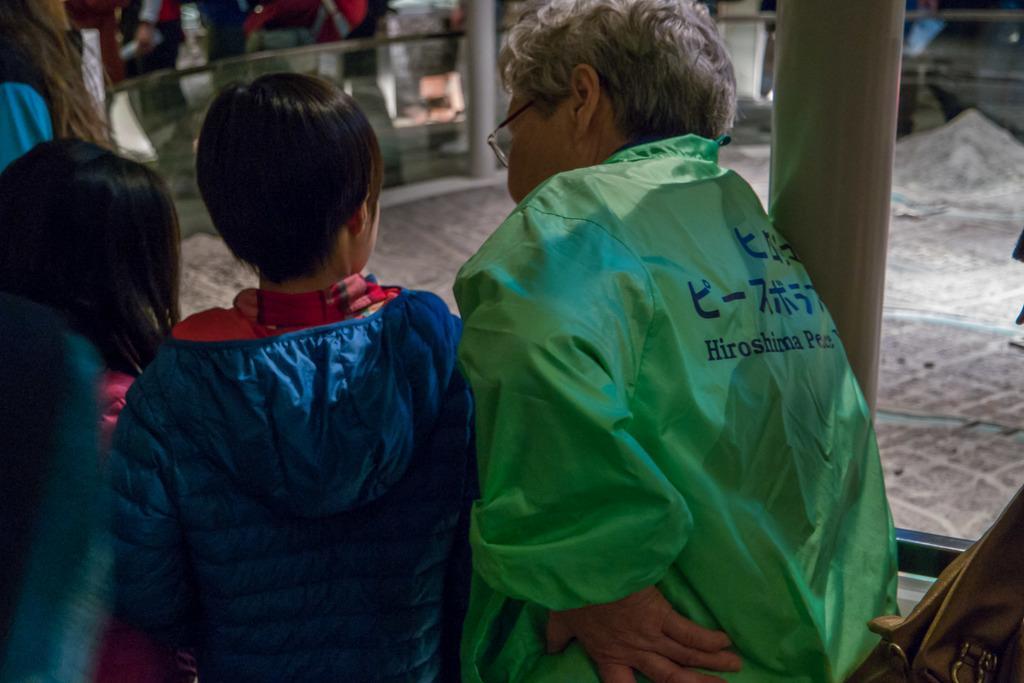Please provide a concise description of this image. In this image I can see few persons standing, the glass railing and the miniature of the city. 